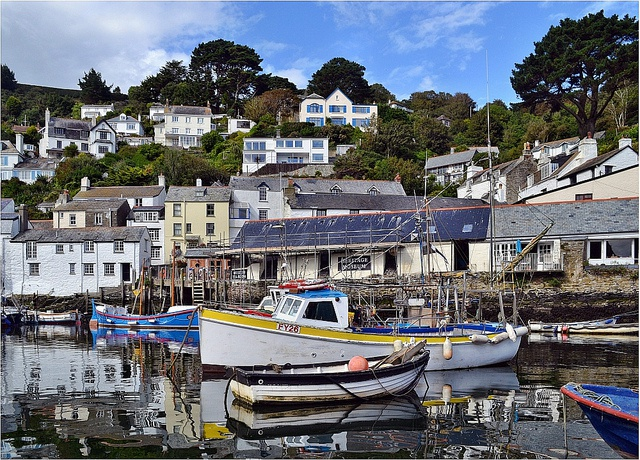Describe the objects in this image and their specific colors. I can see boat in ivory, lightgray, darkgray, black, and gray tones, boat in ivory, black, darkgray, lightgray, and gray tones, boat in ivory, black, navy, gray, and blue tones, boat in ivory, black, darkgray, blue, and lightgray tones, and boat in ivory, black, darkgray, and gray tones in this image. 